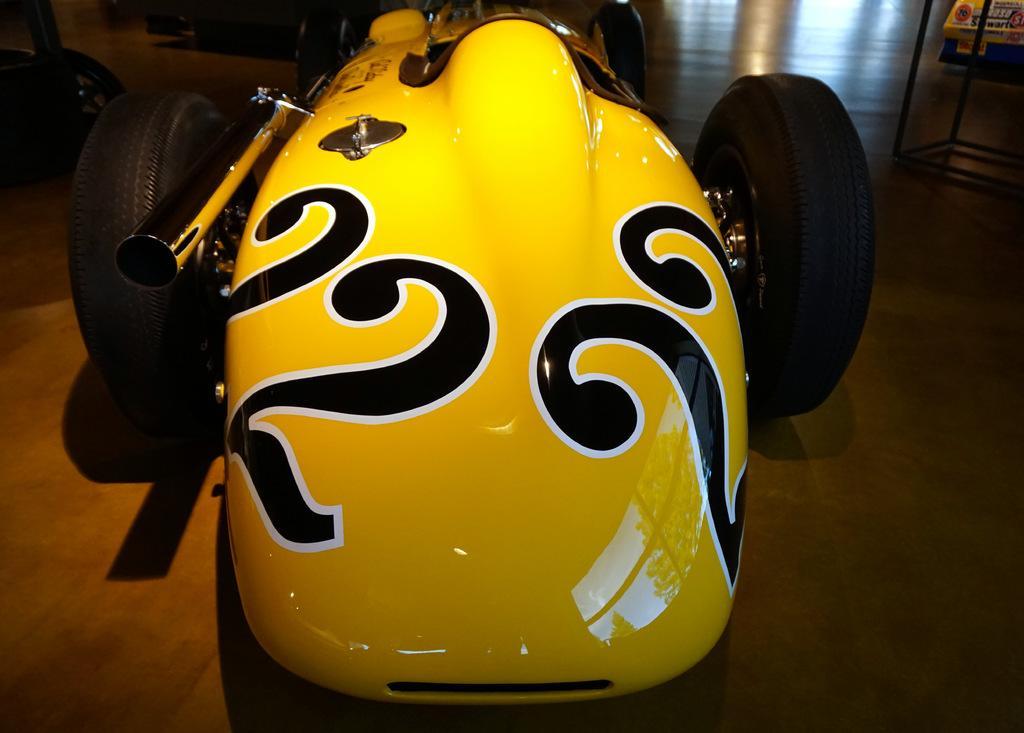How would you summarize this image in a sentence or two? In this image there is a yellow vehicle. In the background there are few other vehicles on the floor. 